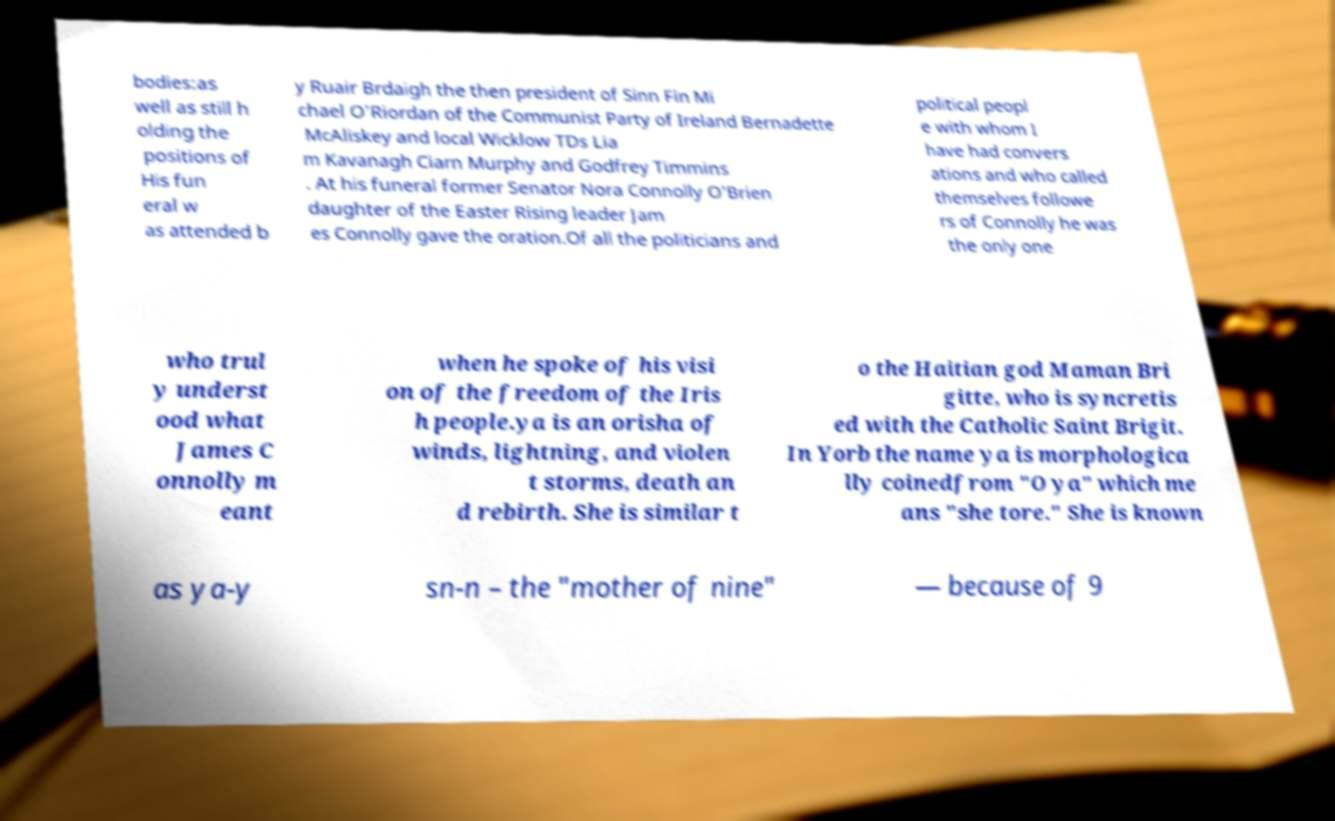Can you read and provide the text displayed in the image?This photo seems to have some interesting text. Can you extract and type it out for me? bodies:as well as still h olding the positions of His fun eral w as attended b y Ruair Brdaigh the then president of Sinn Fin Mi chael O'Riordan of the Communist Party of Ireland Bernadette McAliskey and local Wicklow TDs Lia m Kavanagh Ciarn Murphy and Godfrey Timmins . At his funeral former Senator Nora Connolly O'Brien daughter of the Easter Rising leader Jam es Connolly gave the oration.Of all the politicians and political peopl e with whom I have had convers ations and who called themselves followe rs of Connolly he was the only one who trul y underst ood what James C onnolly m eant when he spoke of his visi on of the freedom of the Iris h people.ya is an orisha of winds, lightning, and violen t storms, death an d rebirth. She is similar t o the Haitian god Maman Bri gitte, who is syncretis ed with the Catholic Saint Brigit. In Yorb the name ya is morphologica lly coinedfrom "O ya" which me ans "she tore." She is known as ya-y sn-n – the "mother of nine" — because of 9 